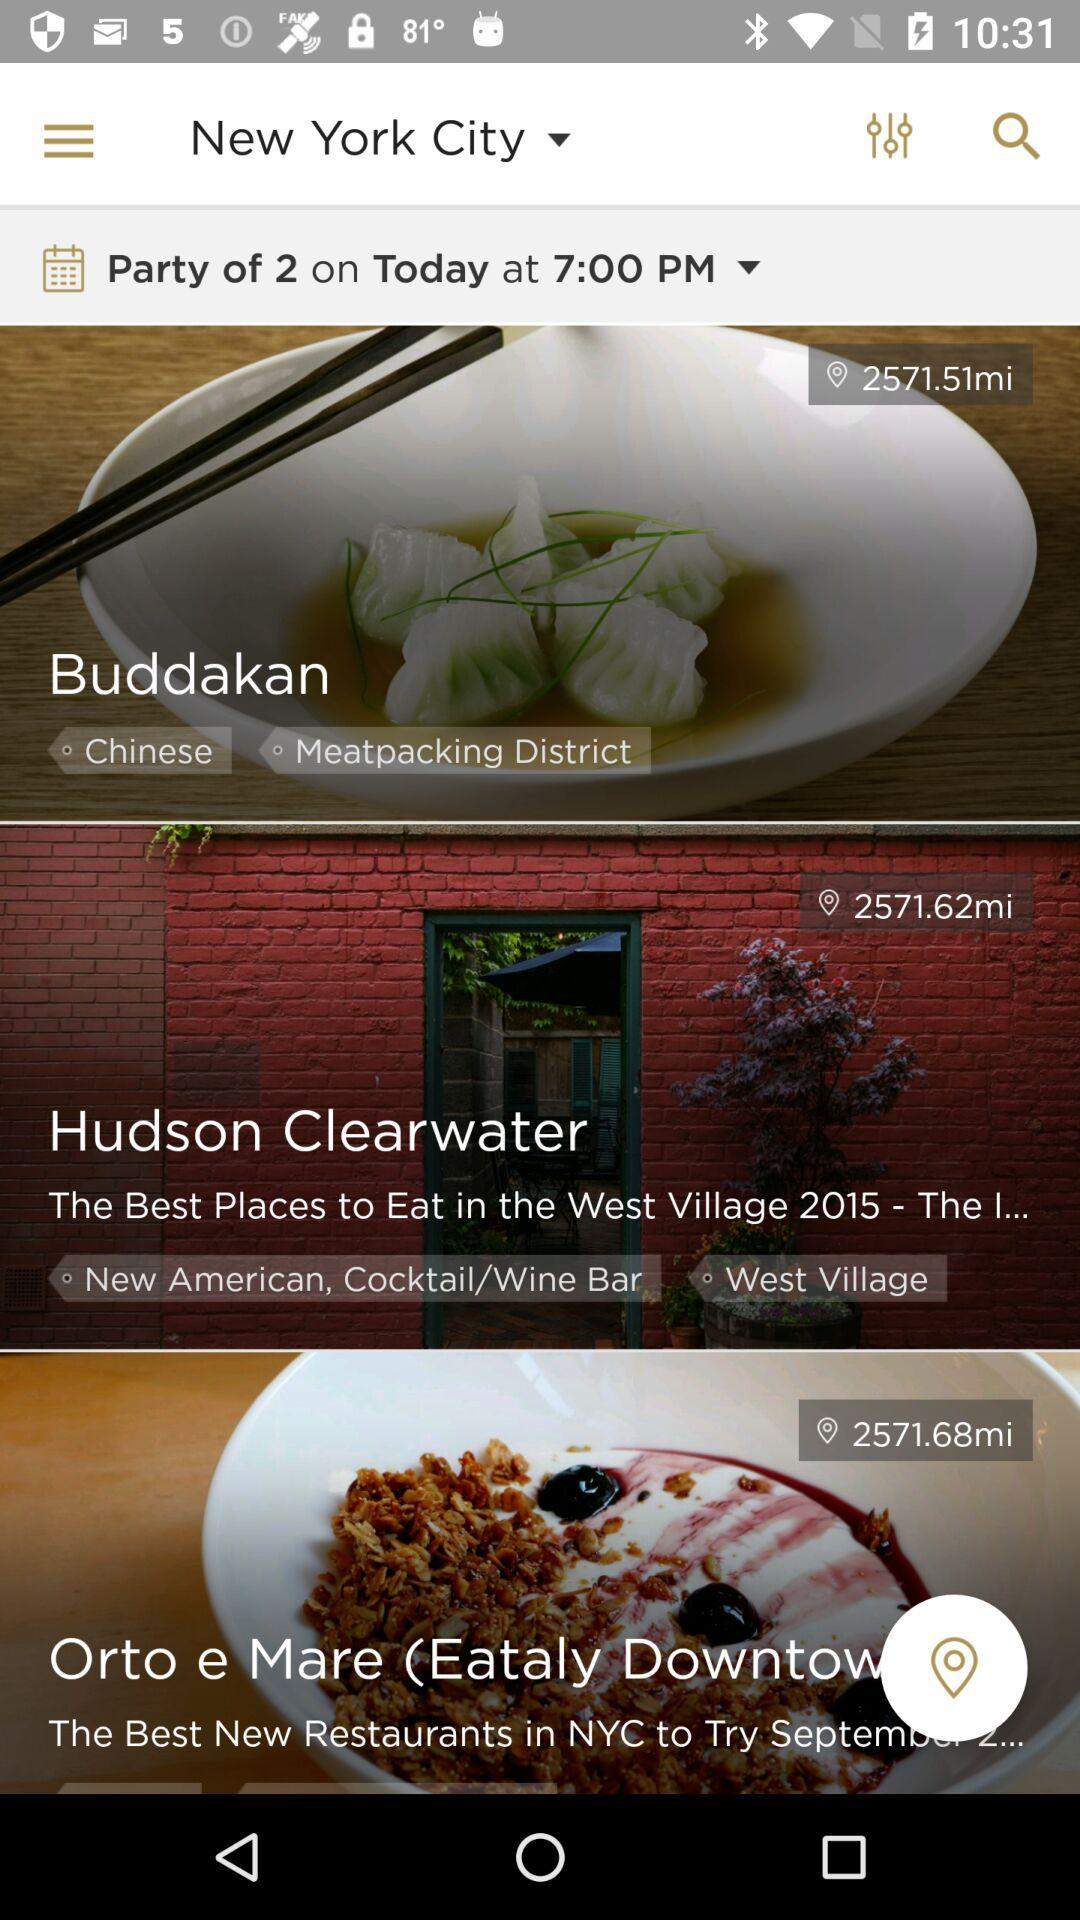What is the mentioned location? The mentioned location is New York City. 